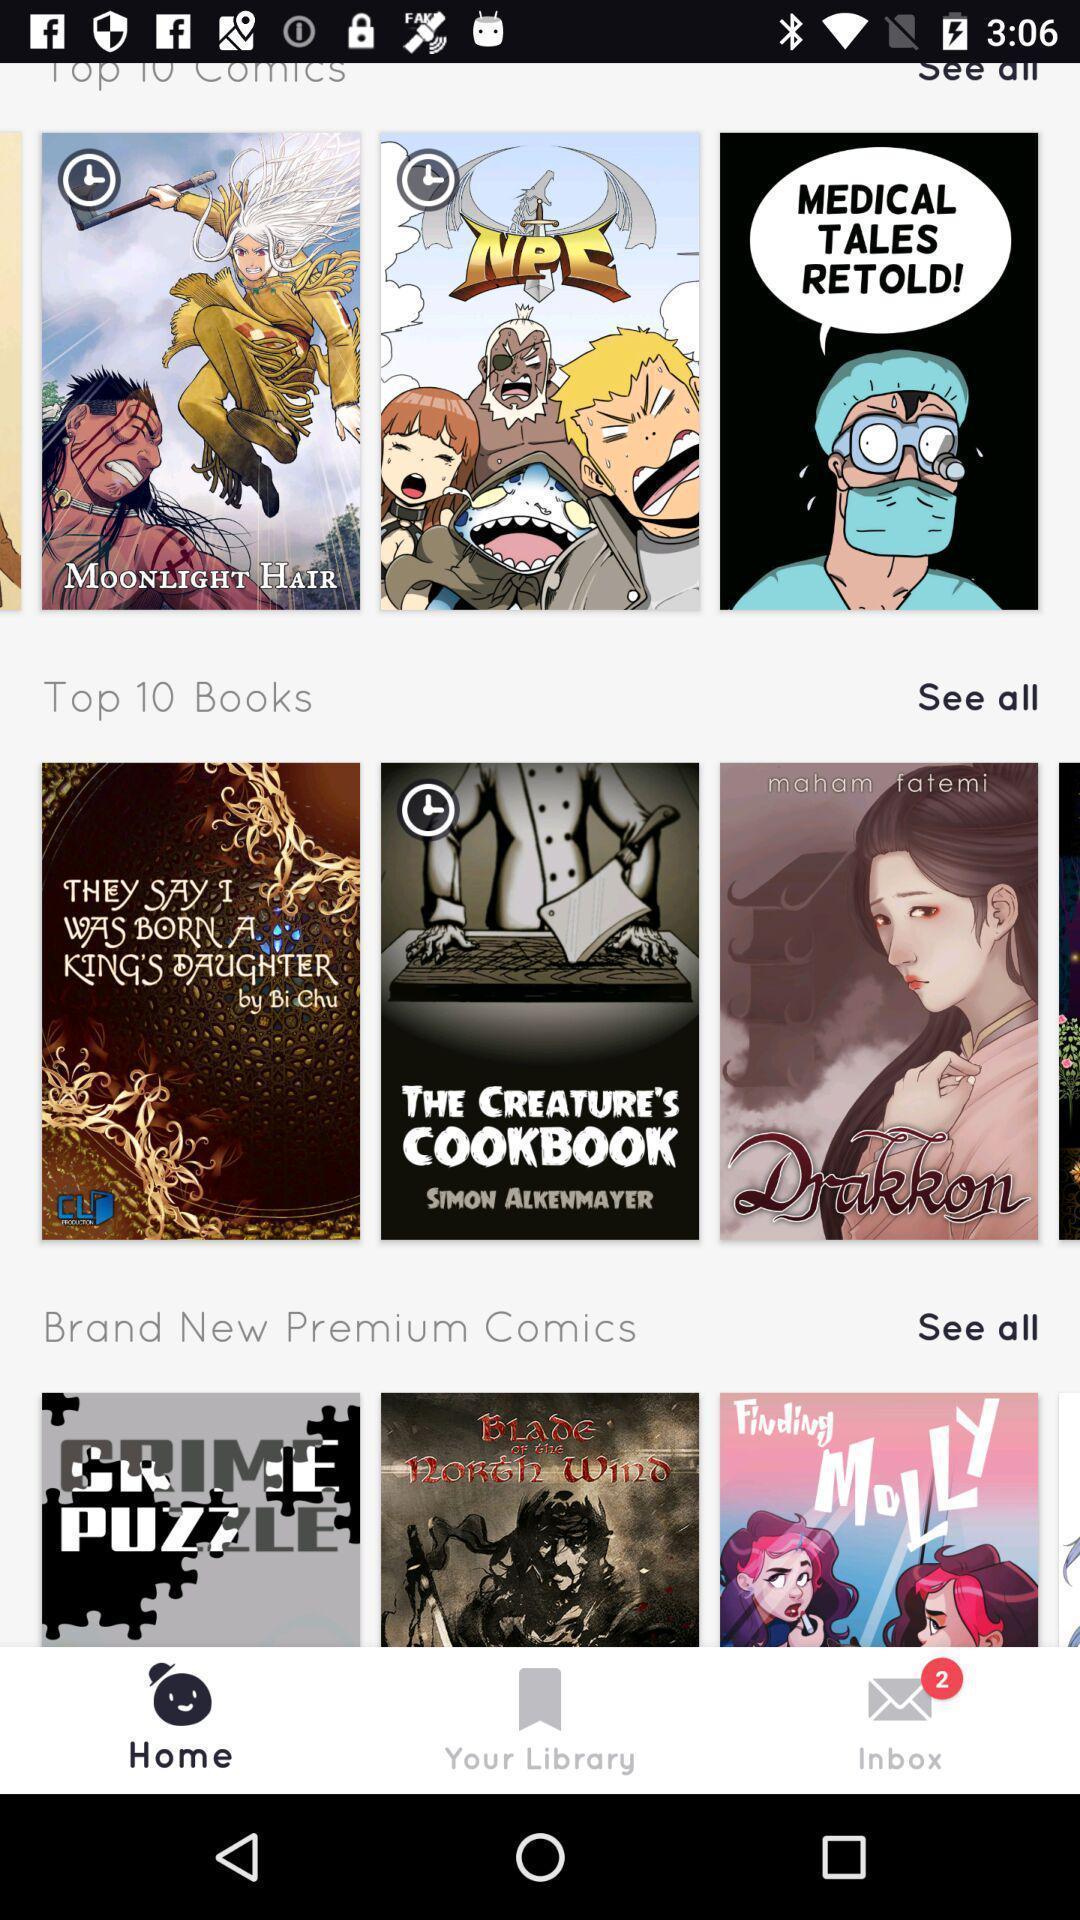Give me a summary of this screen capture. Page showing list of comics on an app. 